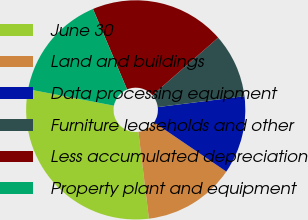Convert chart to OTSL. <chart><loc_0><loc_0><loc_500><loc_500><pie_chart><fcel>June 30<fcel>Land and buildings<fcel>Data processing equipment<fcel>Furniture leaseholds and other<fcel>Less accumulated depreciation<fcel>Property plant and equipment<nl><fcel>29.95%<fcel>13.56%<fcel>11.51%<fcel>9.46%<fcel>19.93%<fcel>15.6%<nl></chart> 